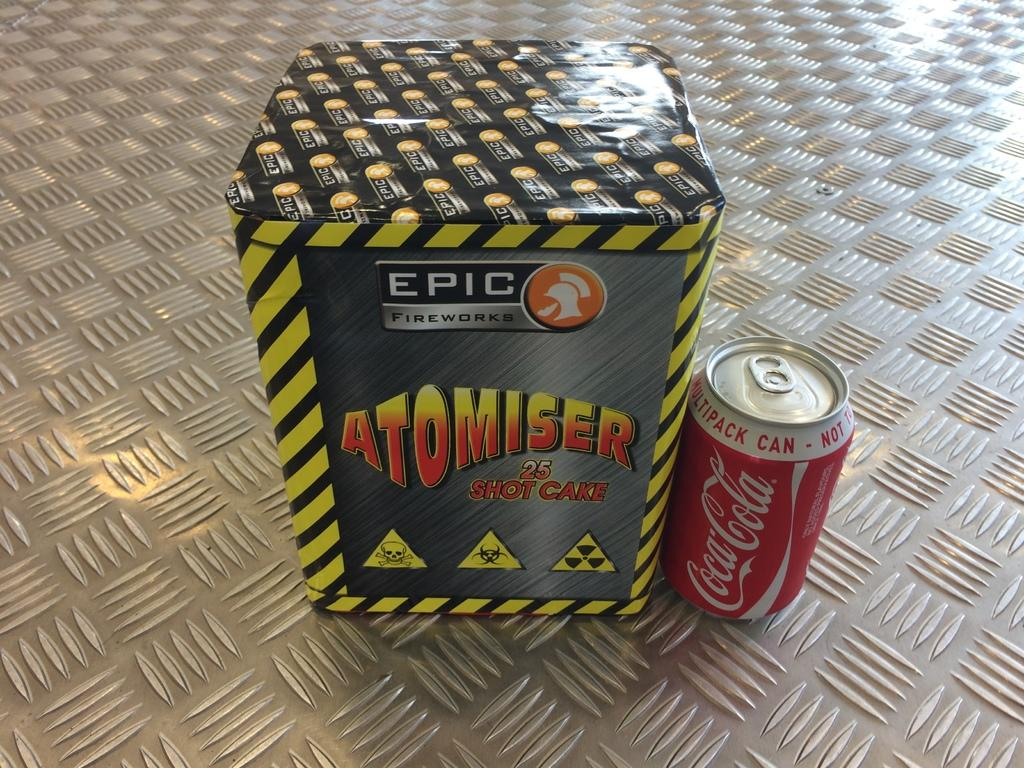What is one of the objects in the image? There is a box in the image. What is another object in the image? There is a soft drink tin in the image. Where are these objects located in the image? Both objects are in the center of the image. What day of the week is depicted in the image? There is no indication of a specific day of the week in the image. What type of adjustment is being made to the box in the image? There is no adjustment being made to the box in the image; it is stationary. 